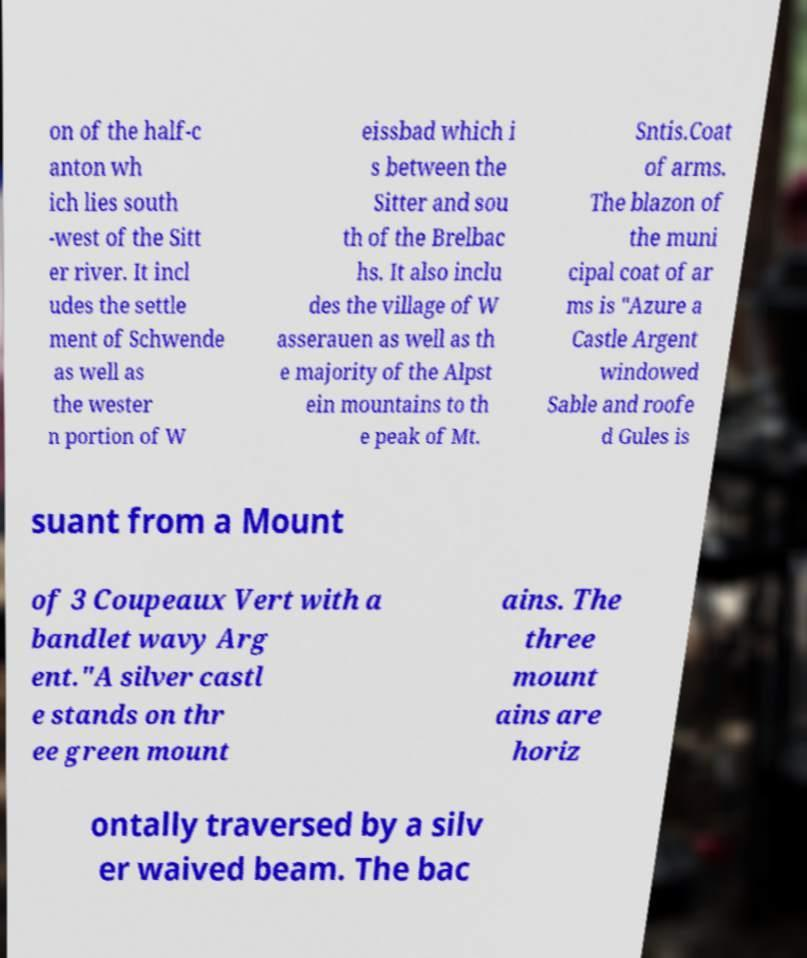Could you assist in decoding the text presented in this image and type it out clearly? on of the half-c anton wh ich lies south -west of the Sitt er river. It incl udes the settle ment of Schwende as well as the wester n portion of W eissbad which i s between the Sitter and sou th of the Brelbac hs. It also inclu des the village of W asserauen as well as th e majority of the Alpst ein mountains to th e peak of Mt. Sntis.Coat of arms. The blazon of the muni cipal coat of ar ms is "Azure a Castle Argent windowed Sable and roofe d Gules is suant from a Mount of 3 Coupeaux Vert with a bandlet wavy Arg ent."A silver castl e stands on thr ee green mount ains. The three mount ains are horiz ontally traversed by a silv er waived beam. The bac 